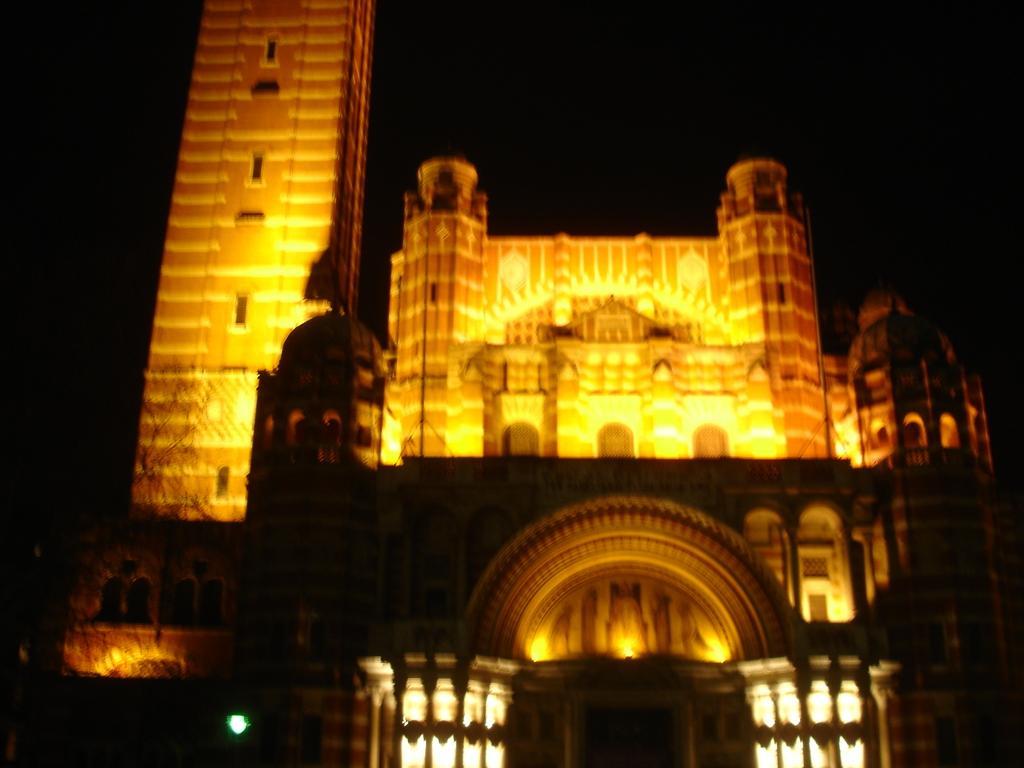Can you describe this image briefly? In this image we can see a building with tower and some lights. 